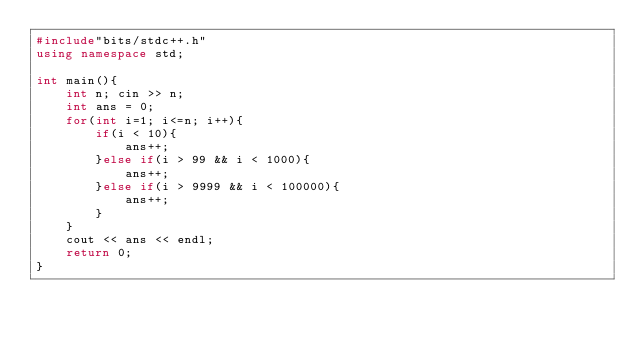<code> <loc_0><loc_0><loc_500><loc_500><_C++_>#include"bits/stdc++.h"
using namespace std;

int main(){
    int n; cin >> n;
    int ans = 0;
    for(int i=1; i<=n; i++){
        if(i < 10){
            ans++;
        }else if(i > 99 && i < 1000){
            ans++;
        }else if(i > 9999 && i < 100000){
            ans++;
        }
    }
    cout << ans << endl;
    return 0;
}</code> 